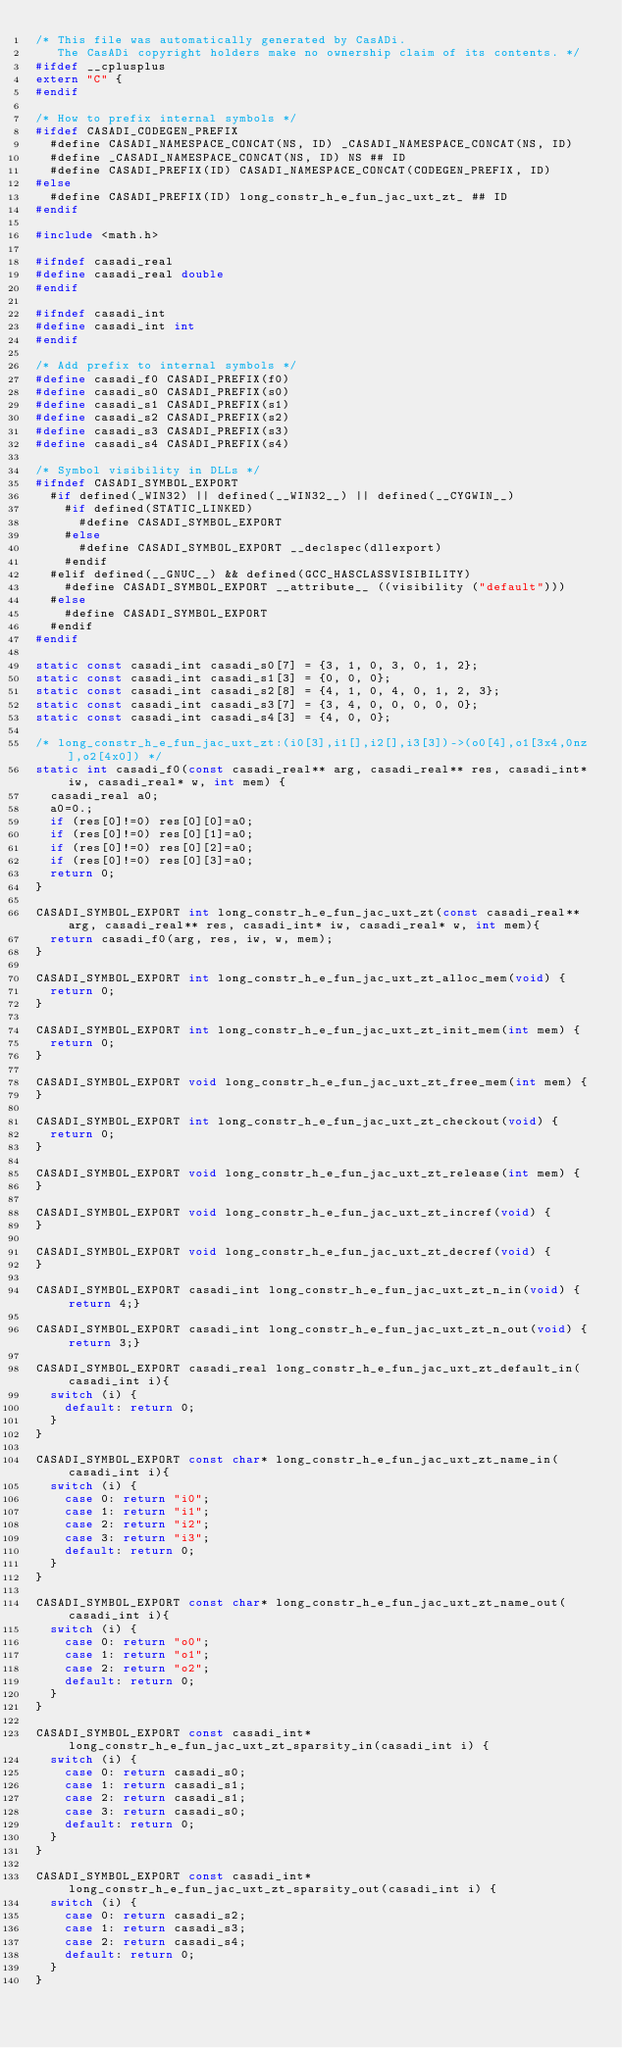Convert code to text. <code><loc_0><loc_0><loc_500><loc_500><_C_>/* This file was automatically generated by CasADi.
   The CasADi copyright holders make no ownership claim of its contents. */
#ifdef __cplusplus
extern "C" {
#endif

/* How to prefix internal symbols */
#ifdef CASADI_CODEGEN_PREFIX
  #define CASADI_NAMESPACE_CONCAT(NS, ID) _CASADI_NAMESPACE_CONCAT(NS, ID)
  #define _CASADI_NAMESPACE_CONCAT(NS, ID) NS ## ID
  #define CASADI_PREFIX(ID) CASADI_NAMESPACE_CONCAT(CODEGEN_PREFIX, ID)
#else
  #define CASADI_PREFIX(ID) long_constr_h_e_fun_jac_uxt_zt_ ## ID
#endif

#include <math.h>

#ifndef casadi_real
#define casadi_real double
#endif

#ifndef casadi_int
#define casadi_int int
#endif

/* Add prefix to internal symbols */
#define casadi_f0 CASADI_PREFIX(f0)
#define casadi_s0 CASADI_PREFIX(s0)
#define casadi_s1 CASADI_PREFIX(s1)
#define casadi_s2 CASADI_PREFIX(s2)
#define casadi_s3 CASADI_PREFIX(s3)
#define casadi_s4 CASADI_PREFIX(s4)

/* Symbol visibility in DLLs */
#ifndef CASADI_SYMBOL_EXPORT
  #if defined(_WIN32) || defined(__WIN32__) || defined(__CYGWIN__)
    #if defined(STATIC_LINKED)
      #define CASADI_SYMBOL_EXPORT
    #else
      #define CASADI_SYMBOL_EXPORT __declspec(dllexport)
    #endif
  #elif defined(__GNUC__) && defined(GCC_HASCLASSVISIBILITY)
    #define CASADI_SYMBOL_EXPORT __attribute__ ((visibility ("default")))
  #else
    #define CASADI_SYMBOL_EXPORT
  #endif
#endif

static const casadi_int casadi_s0[7] = {3, 1, 0, 3, 0, 1, 2};
static const casadi_int casadi_s1[3] = {0, 0, 0};
static const casadi_int casadi_s2[8] = {4, 1, 0, 4, 0, 1, 2, 3};
static const casadi_int casadi_s3[7] = {3, 4, 0, 0, 0, 0, 0};
static const casadi_int casadi_s4[3] = {4, 0, 0};

/* long_constr_h_e_fun_jac_uxt_zt:(i0[3],i1[],i2[],i3[3])->(o0[4],o1[3x4,0nz],o2[4x0]) */
static int casadi_f0(const casadi_real** arg, casadi_real** res, casadi_int* iw, casadi_real* w, int mem) {
  casadi_real a0;
  a0=0.;
  if (res[0]!=0) res[0][0]=a0;
  if (res[0]!=0) res[0][1]=a0;
  if (res[0]!=0) res[0][2]=a0;
  if (res[0]!=0) res[0][3]=a0;
  return 0;
}

CASADI_SYMBOL_EXPORT int long_constr_h_e_fun_jac_uxt_zt(const casadi_real** arg, casadi_real** res, casadi_int* iw, casadi_real* w, int mem){
  return casadi_f0(arg, res, iw, w, mem);
}

CASADI_SYMBOL_EXPORT int long_constr_h_e_fun_jac_uxt_zt_alloc_mem(void) {
  return 0;
}

CASADI_SYMBOL_EXPORT int long_constr_h_e_fun_jac_uxt_zt_init_mem(int mem) {
  return 0;
}

CASADI_SYMBOL_EXPORT void long_constr_h_e_fun_jac_uxt_zt_free_mem(int mem) {
}

CASADI_SYMBOL_EXPORT int long_constr_h_e_fun_jac_uxt_zt_checkout(void) {
  return 0;
}

CASADI_SYMBOL_EXPORT void long_constr_h_e_fun_jac_uxt_zt_release(int mem) {
}

CASADI_SYMBOL_EXPORT void long_constr_h_e_fun_jac_uxt_zt_incref(void) {
}

CASADI_SYMBOL_EXPORT void long_constr_h_e_fun_jac_uxt_zt_decref(void) {
}

CASADI_SYMBOL_EXPORT casadi_int long_constr_h_e_fun_jac_uxt_zt_n_in(void) { return 4;}

CASADI_SYMBOL_EXPORT casadi_int long_constr_h_e_fun_jac_uxt_zt_n_out(void) { return 3;}

CASADI_SYMBOL_EXPORT casadi_real long_constr_h_e_fun_jac_uxt_zt_default_in(casadi_int i){
  switch (i) {
    default: return 0;
  }
}

CASADI_SYMBOL_EXPORT const char* long_constr_h_e_fun_jac_uxt_zt_name_in(casadi_int i){
  switch (i) {
    case 0: return "i0";
    case 1: return "i1";
    case 2: return "i2";
    case 3: return "i3";
    default: return 0;
  }
}

CASADI_SYMBOL_EXPORT const char* long_constr_h_e_fun_jac_uxt_zt_name_out(casadi_int i){
  switch (i) {
    case 0: return "o0";
    case 1: return "o1";
    case 2: return "o2";
    default: return 0;
  }
}

CASADI_SYMBOL_EXPORT const casadi_int* long_constr_h_e_fun_jac_uxt_zt_sparsity_in(casadi_int i) {
  switch (i) {
    case 0: return casadi_s0;
    case 1: return casadi_s1;
    case 2: return casadi_s1;
    case 3: return casadi_s0;
    default: return 0;
  }
}

CASADI_SYMBOL_EXPORT const casadi_int* long_constr_h_e_fun_jac_uxt_zt_sparsity_out(casadi_int i) {
  switch (i) {
    case 0: return casadi_s2;
    case 1: return casadi_s3;
    case 2: return casadi_s4;
    default: return 0;
  }
}
</code> 